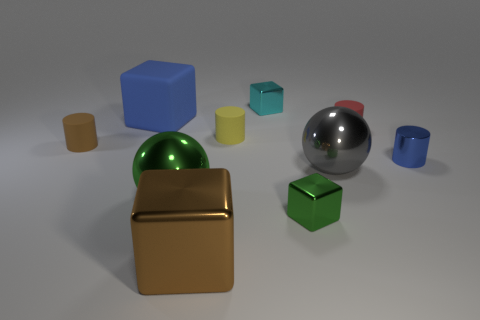Which object stands out the most, and why? The gold-colored cube stands out the most due to its larger size, distinct color that contrasts with the rest, and its central position in the image. 